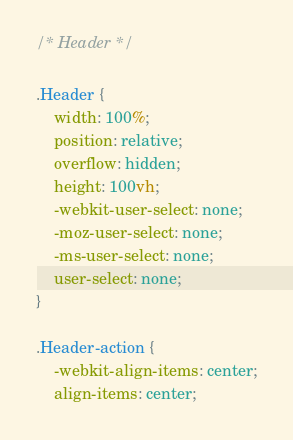<code> <loc_0><loc_0><loc_500><loc_500><_CSS_>
/* Header */

.Header {
	width: 100%;
	position: relative;
	overflow: hidden;
	height: 100vh;
	-webkit-user-select: none;
	-moz-user-select: none;
	-ms-user-select: none;
	user-select: none;
}

.Header-action {
	-webkit-align-items: center;
	align-items: center;</code> 